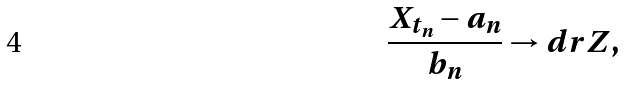<formula> <loc_0><loc_0><loc_500><loc_500>\frac { X _ { t _ { n } } - a _ { n } } { b _ { n } } \to d r Z ,</formula> 